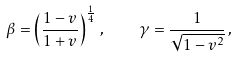Convert formula to latex. <formula><loc_0><loc_0><loc_500><loc_500>\beta = \left ( \frac { 1 - v } { 1 + v } \right ) ^ { \frac { 1 } { 4 } } \, , \quad \gamma = \frac { 1 } { \sqrt { 1 - v ^ { 2 } } } \, ,</formula> 